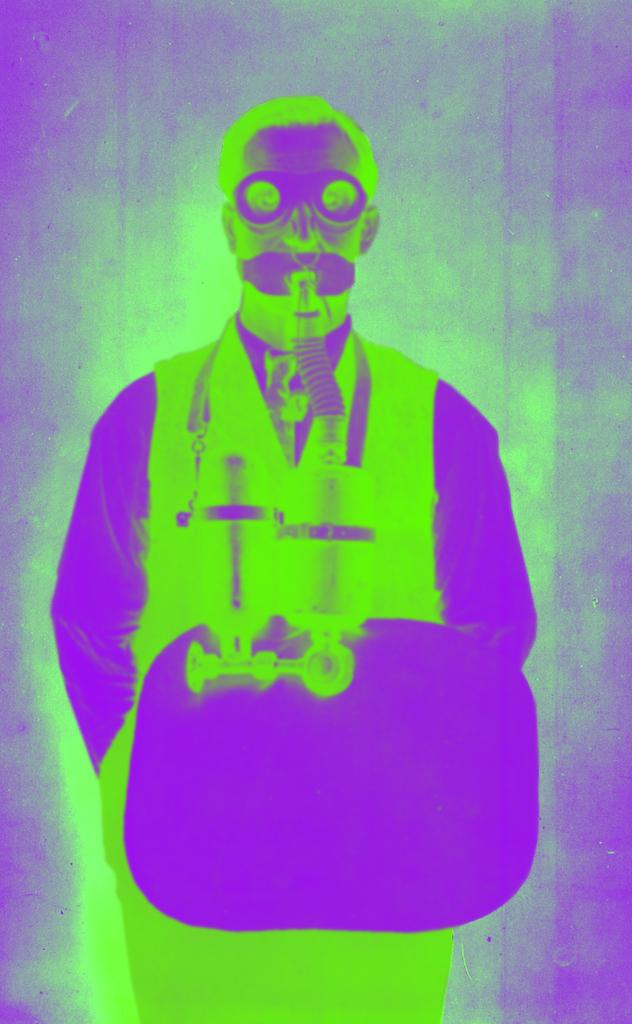What type of image is being described? The image is an edited image. Who or what is the main focus of the image? The subject of the image is a person. What type of skirt is the sheep wearing in the image? There is no sheep or skirt present in the image; the subject is a person. 